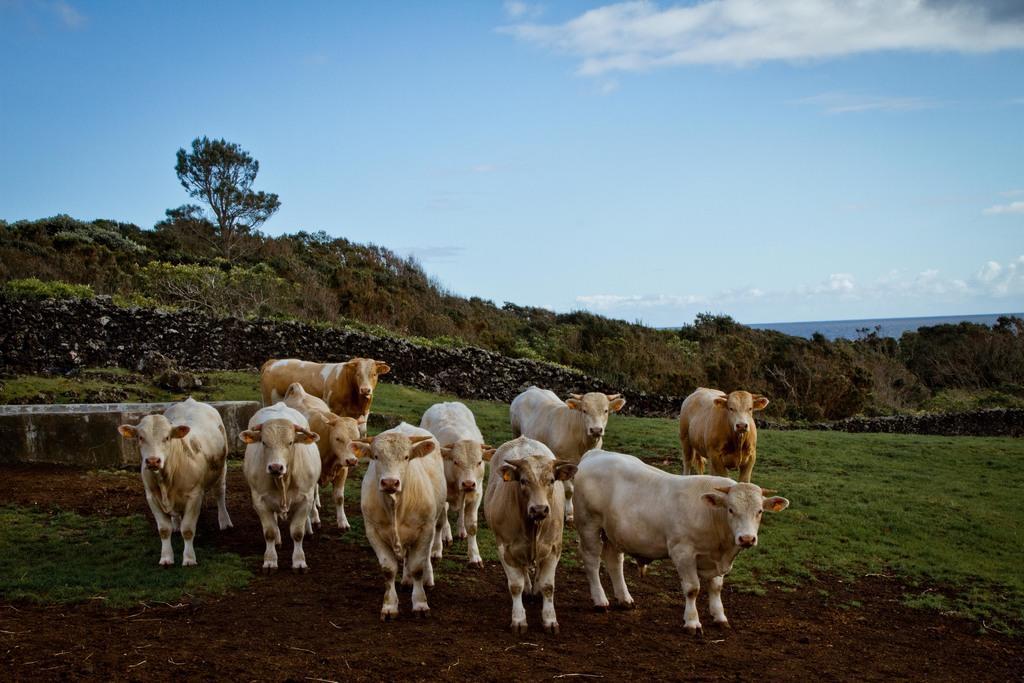Describe this image in one or two sentences. In this image we can see cows, grass, trees and sky. Clouds are in the sky. 